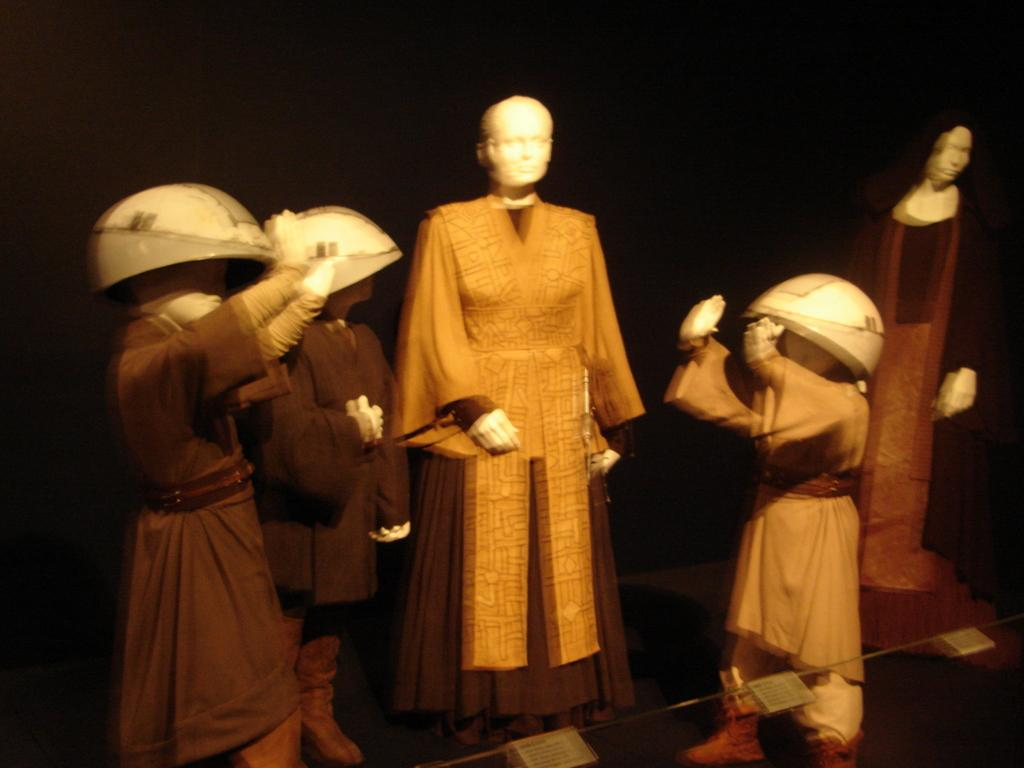What is the main subject of the image? The main subject of the image is a group of mannequins. What are the mannequins doing in the image? The mannequins are standing in the image. What color is the dress that can be seen in the image? There is a brown-colored dress in the image. How would you describe the background of the image? The background of the image is dark. How many divisions can be seen in the image? There are no divisions present in the image; it features a group of standing mannequins and a brown-colored dress. Are there any brothers depicted in the image? There are no people, let alone brothers, depicted in the image; it features a group of mannequins. 